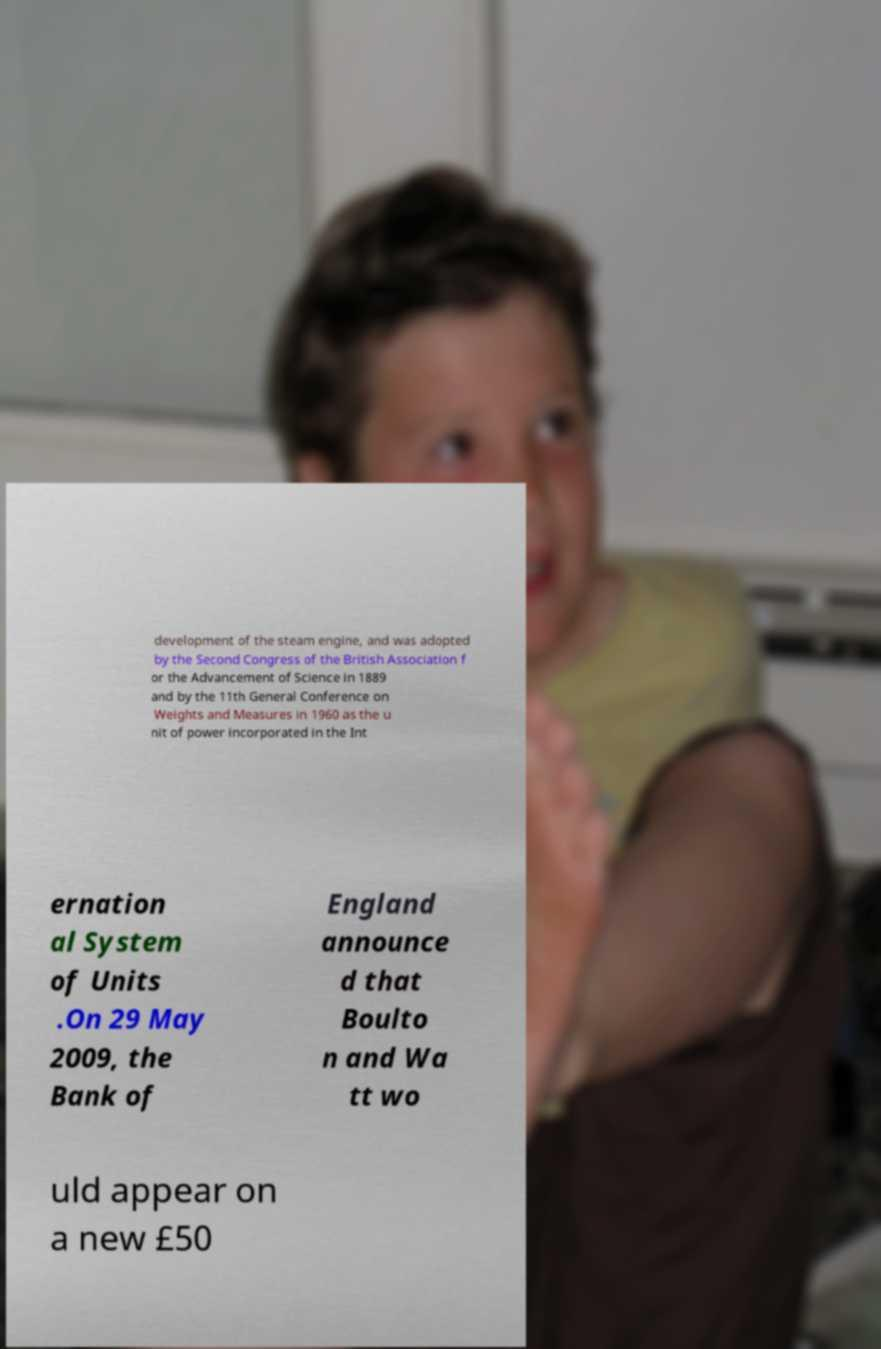For documentation purposes, I need the text within this image transcribed. Could you provide that? development of the steam engine, and was adopted by the Second Congress of the British Association f or the Advancement of Science in 1889 and by the 11th General Conference on Weights and Measures in 1960 as the u nit of power incorporated in the Int ernation al System of Units .On 29 May 2009, the Bank of England announce d that Boulto n and Wa tt wo uld appear on a new £50 